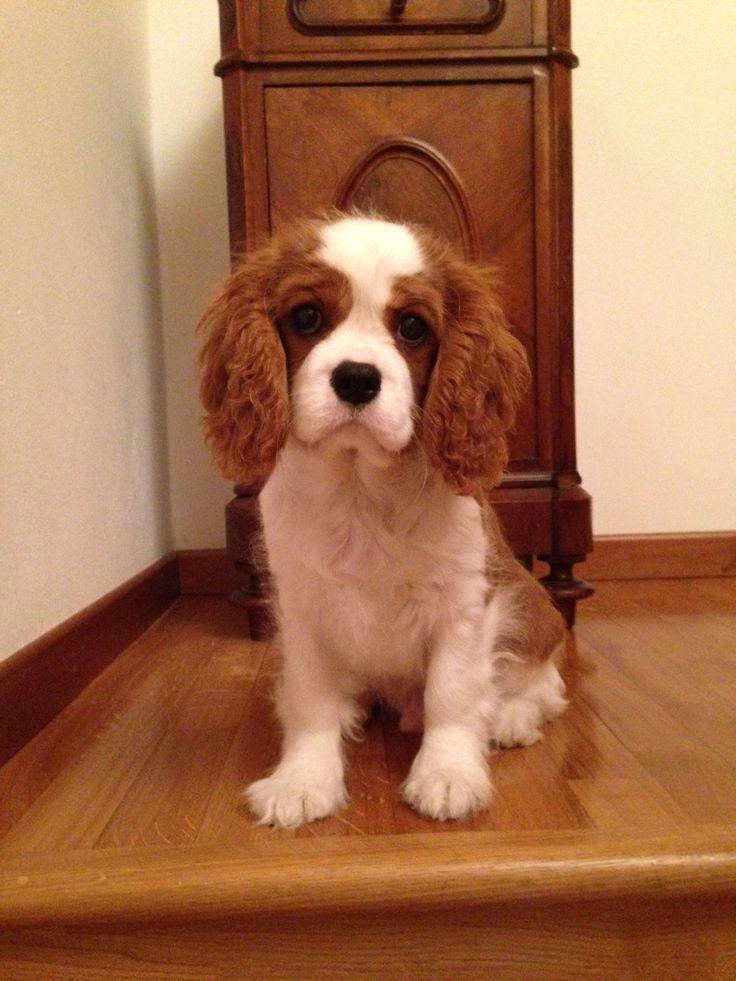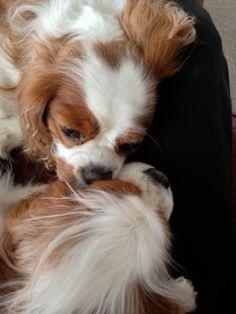The first image is the image on the left, the second image is the image on the right. Evaluate the accuracy of this statement regarding the images: "There are three dogs, and one is looking straight at the camera.". Is it true? Answer yes or no. Yes. The first image is the image on the left, the second image is the image on the right. Given the left and right images, does the statement "There is a single brown and white cocker spaniel looking left." hold true? Answer yes or no. No. 